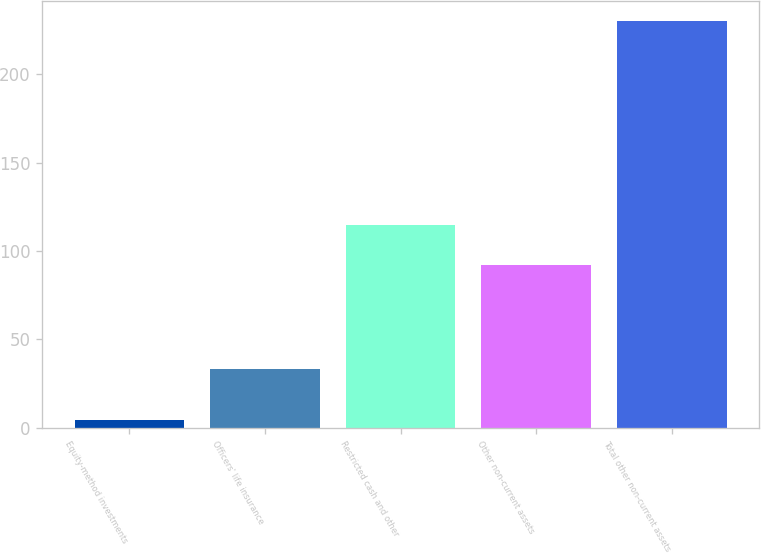Convert chart. <chart><loc_0><loc_0><loc_500><loc_500><bar_chart><fcel>Equity-method investments<fcel>Officers' life insurance<fcel>Restricted cash and other<fcel>Other non-current assets<fcel>Total other non-current assets<nl><fcel>4.2<fcel>32.9<fcel>114.49<fcel>91.9<fcel>230.1<nl></chart> 